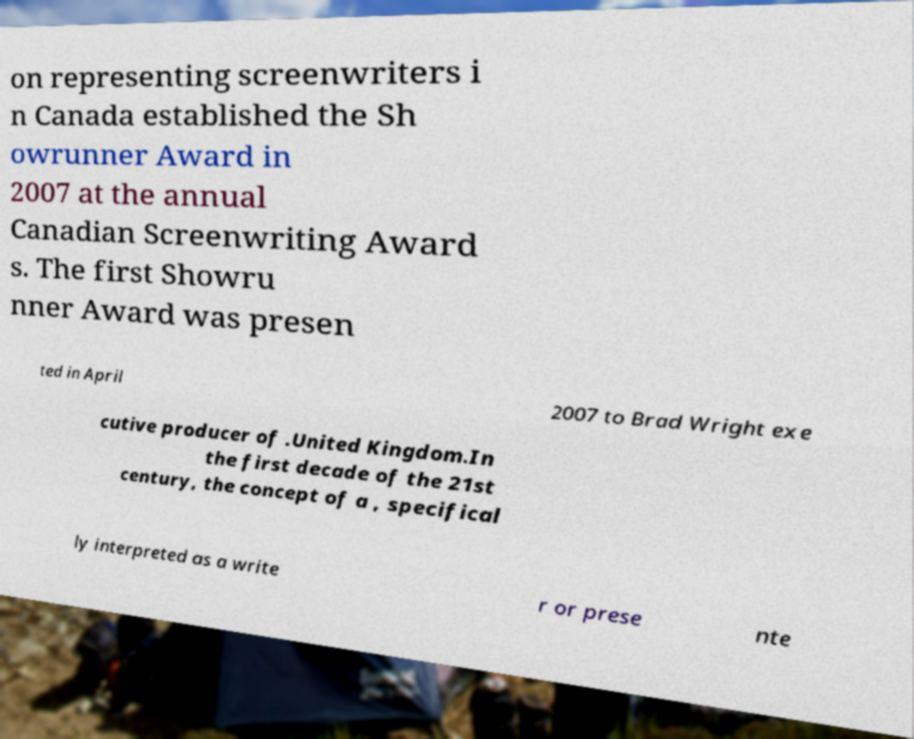Could you extract and type out the text from this image? on representing screenwriters i n Canada established the Sh owrunner Award in 2007 at the annual Canadian Screenwriting Award s. The first Showru nner Award was presen ted in April 2007 to Brad Wright exe cutive producer of .United Kingdom.In the first decade of the 21st century, the concept of a , specifical ly interpreted as a write r or prese nte 